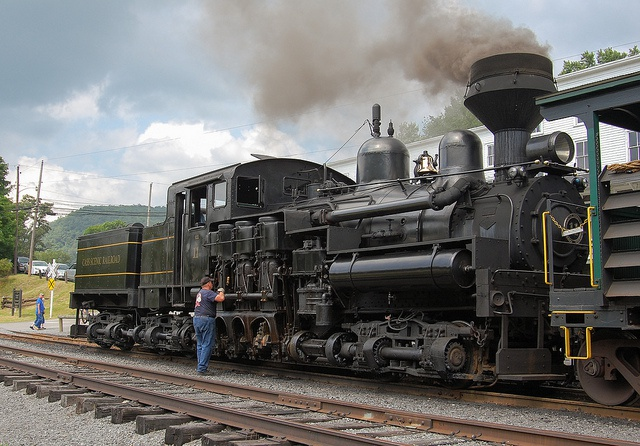Describe the objects in this image and their specific colors. I can see train in darkgray, black, and gray tones, people in darkgray, black, gray, and navy tones, car in darkgray, lightgray, and gray tones, people in darkgray, blue, gray, navy, and lightblue tones, and car in darkgray, gray, and black tones in this image. 